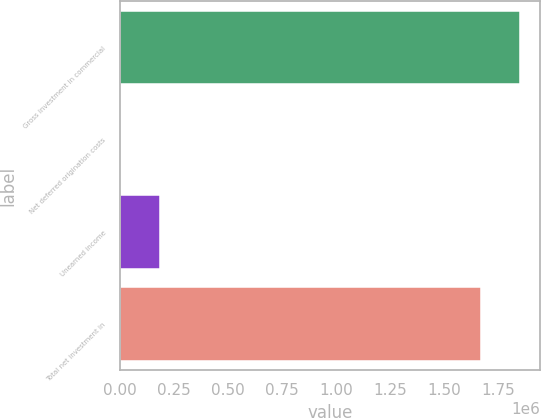<chart> <loc_0><loc_0><loc_500><loc_500><bar_chart><fcel>Gross investment in commercial<fcel>Net deferred origination costs<fcel>Unearned income<fcel>Total net investment in<nl><fcel>1.85025e+06<fcel>2805<fcel>183491<fcel>1.66957e+06<nl></chart> 